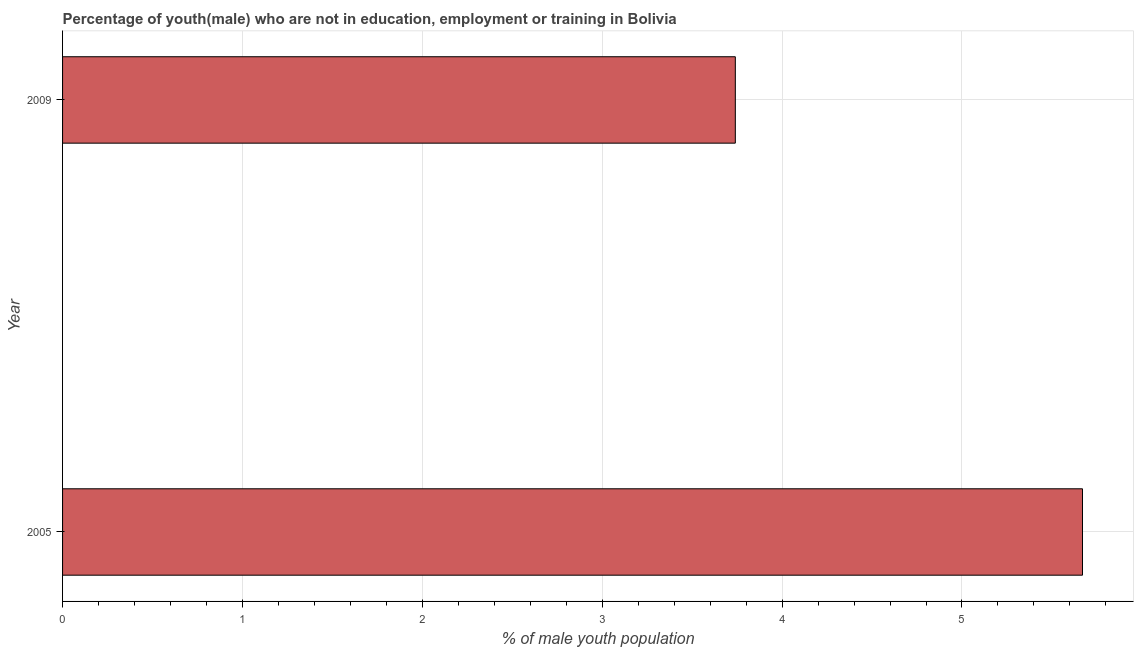Does the graph contain any zero values?
Provide a short and direct response. No. What is the title of the graph?
Offer a terse response. Percentage of youth(male) who are not in education, employment or training in Bolivia. What is the label or title of the X-axis?
Offer a terse response. % of male youth population. What is the label or title of the Y-axis?
Ensure brevity in your answer.  Year. What is the unemployed male youth population in 2009?
Provide a short and direct response. 3.74. Across all years, what is the maximum unemployed male youth population?
Provide a succinct answer. 5.67. Across all years, what is the minimum unemployed male youth population?
Give a very brief answer. 3.74. In which year was the unemployed male youth population maximum?
Keep it short and to the point. 2005. What is the sum of the unemployed male youth population?
Offer a very short reply. 9.41. What is the difference between the unemployed male youth population in 2005 and 2009?
Make the answer very short. 1.93. What is the average unemployed male youth population per year?
Offer a terse response. 4.71. What is the median unemployed male youth population?
Make the answer very short. 4.71. Do a majority of the years between 2009 and 2005 (inclusive) have unemployed male youth population greater than 1.6 %?
Your answer should be compact. No. What is the ratio of the unemployed male youth population in 2005 to that in 2009?
Provide a succinct answer. 1.52. How many bars are there?
Give a very brief answer. 2. Are all the bars in the graph horizontal?
Your answer should be compact. Yes. How many years are there in the graph?
Make the answer very short. 2. What is the difference between two consecutive major ticks on the X-axis?
Your answer should be very brief. 1. What is the % of male youth population in 2005?
Provide a succinct answer. 5.67. What is the % of male youth population of 2009?
Your answer should be very brief. 3.74. What is the difference between the % of male youth population in 2005 and 2009?
Make the answer very short. 1.93. What is the ratio of the % of male youth population in 2005 to that in 2009?
Ensure brevity in your answer.  1.52. 